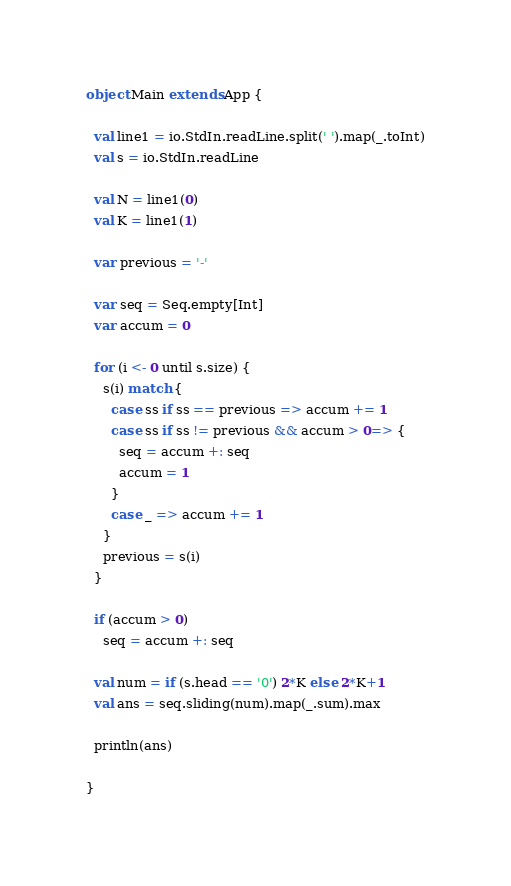<code> <loc_0><loc_0><loc_500><loc_500><_Scala_>object Main extends App {

  val line1 = io.StdIn.readLine.split(' ').map(_.toInt)
  val s = io.StdIn.readLine

  val N = line1(0)
  val K = line1(1)

  var previous = '-'

  var seq = Seq.empty[Int]
  var accum = 0

  for (i <- 0 until s.size) {
    s(i) match {
      case ss if ss == previous => accum += 1
      case ss if ss != previous && accum > 0=> {
        seq = accum +: seq
        accum = 1
      }
      case _ => accum += 1
    }
    previous = s(i)
  }

  if (accum > 0)
    seq = accum +: seq

  val num = if (s.head == '0') 2*K else 2*K+1
  val ans = seq.sliding(num).map(_.sum).max

  println(ans)

}</code> 